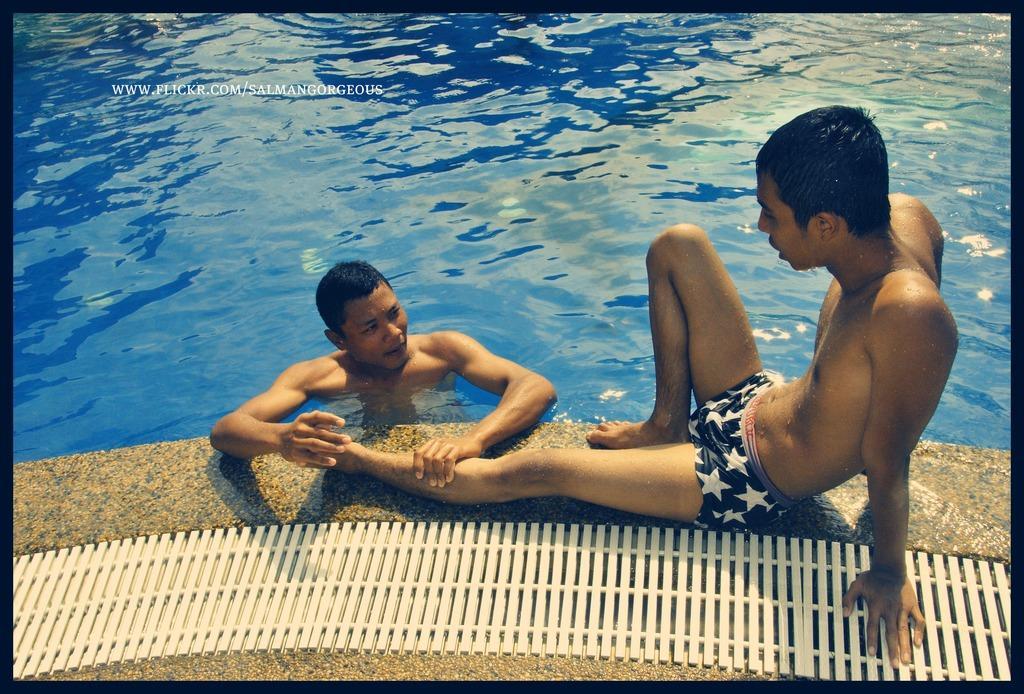Describe this image in one or two sentences. This is the picture of a person in swimming pool looking at another person who is sitting on the floor and we can see some text on the photo 